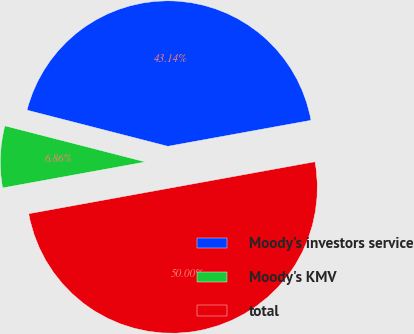Convert chart to OTSL. <chart><loc_0><loc_0><loc_500><loc_500><pie_chart><fcel>Moody's investors service<fcel>Moody's KMV<fcel>total<nl><fcel>43.14%<fcel>6.86%<fcel>50.0%<nl></chart> 